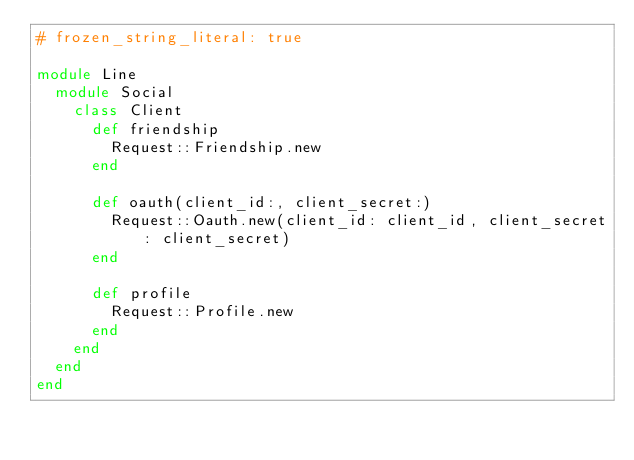Convert code to text. <code><loc_0><loc_0><loc_500><loc_500><_Ruby_># frozen_string_literal: true

module Line
  module Social
    class Client
      def friendship
        Request::Friendship.new
      end

      def oauth(client_id:, client_secret:)
        Request::Oauth.new(client_id: client_id, client_secret: client_secret)
      end

      def profile
        Request::Profile.new
      end
    end
  end
end
</code> 